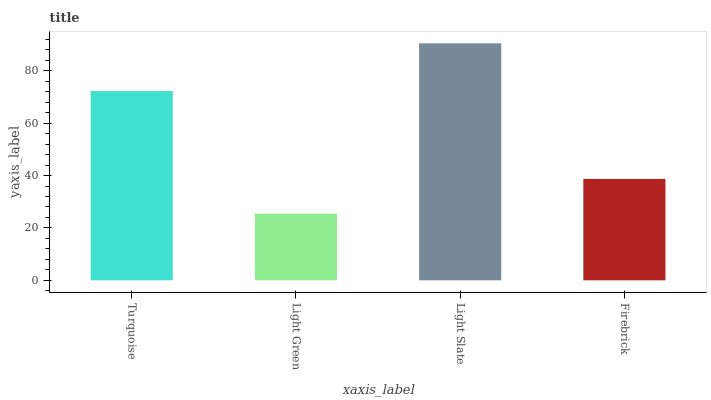Is Light Green the minimum?
Answer yes or no. Yes. Is Light Slate the maximum?
Answer yes or no. Yes. Is Light Slate the minimum?
Answer yes or no. No. Is Light Green the maximum?
Answer yes or no. No. Is Light Slate greater than Light Green?
Answer yes or no. Yes. Is Light Green less than Light Slate?
Answer yes or no. Yes. Is Light Green greater than Light Slate?
Answer yes or no. No. Is Light Slate less than Light Green?
Answer yes or no. No. Is Turquoise the high median?
Answer yes or no. Yes. Is Firebrick the low median?
Answer yes or no. Yes. Is Light Slate the high median?
Answer yes or no. No. Is Light Slate the low median?
Answer yes or no. No. 